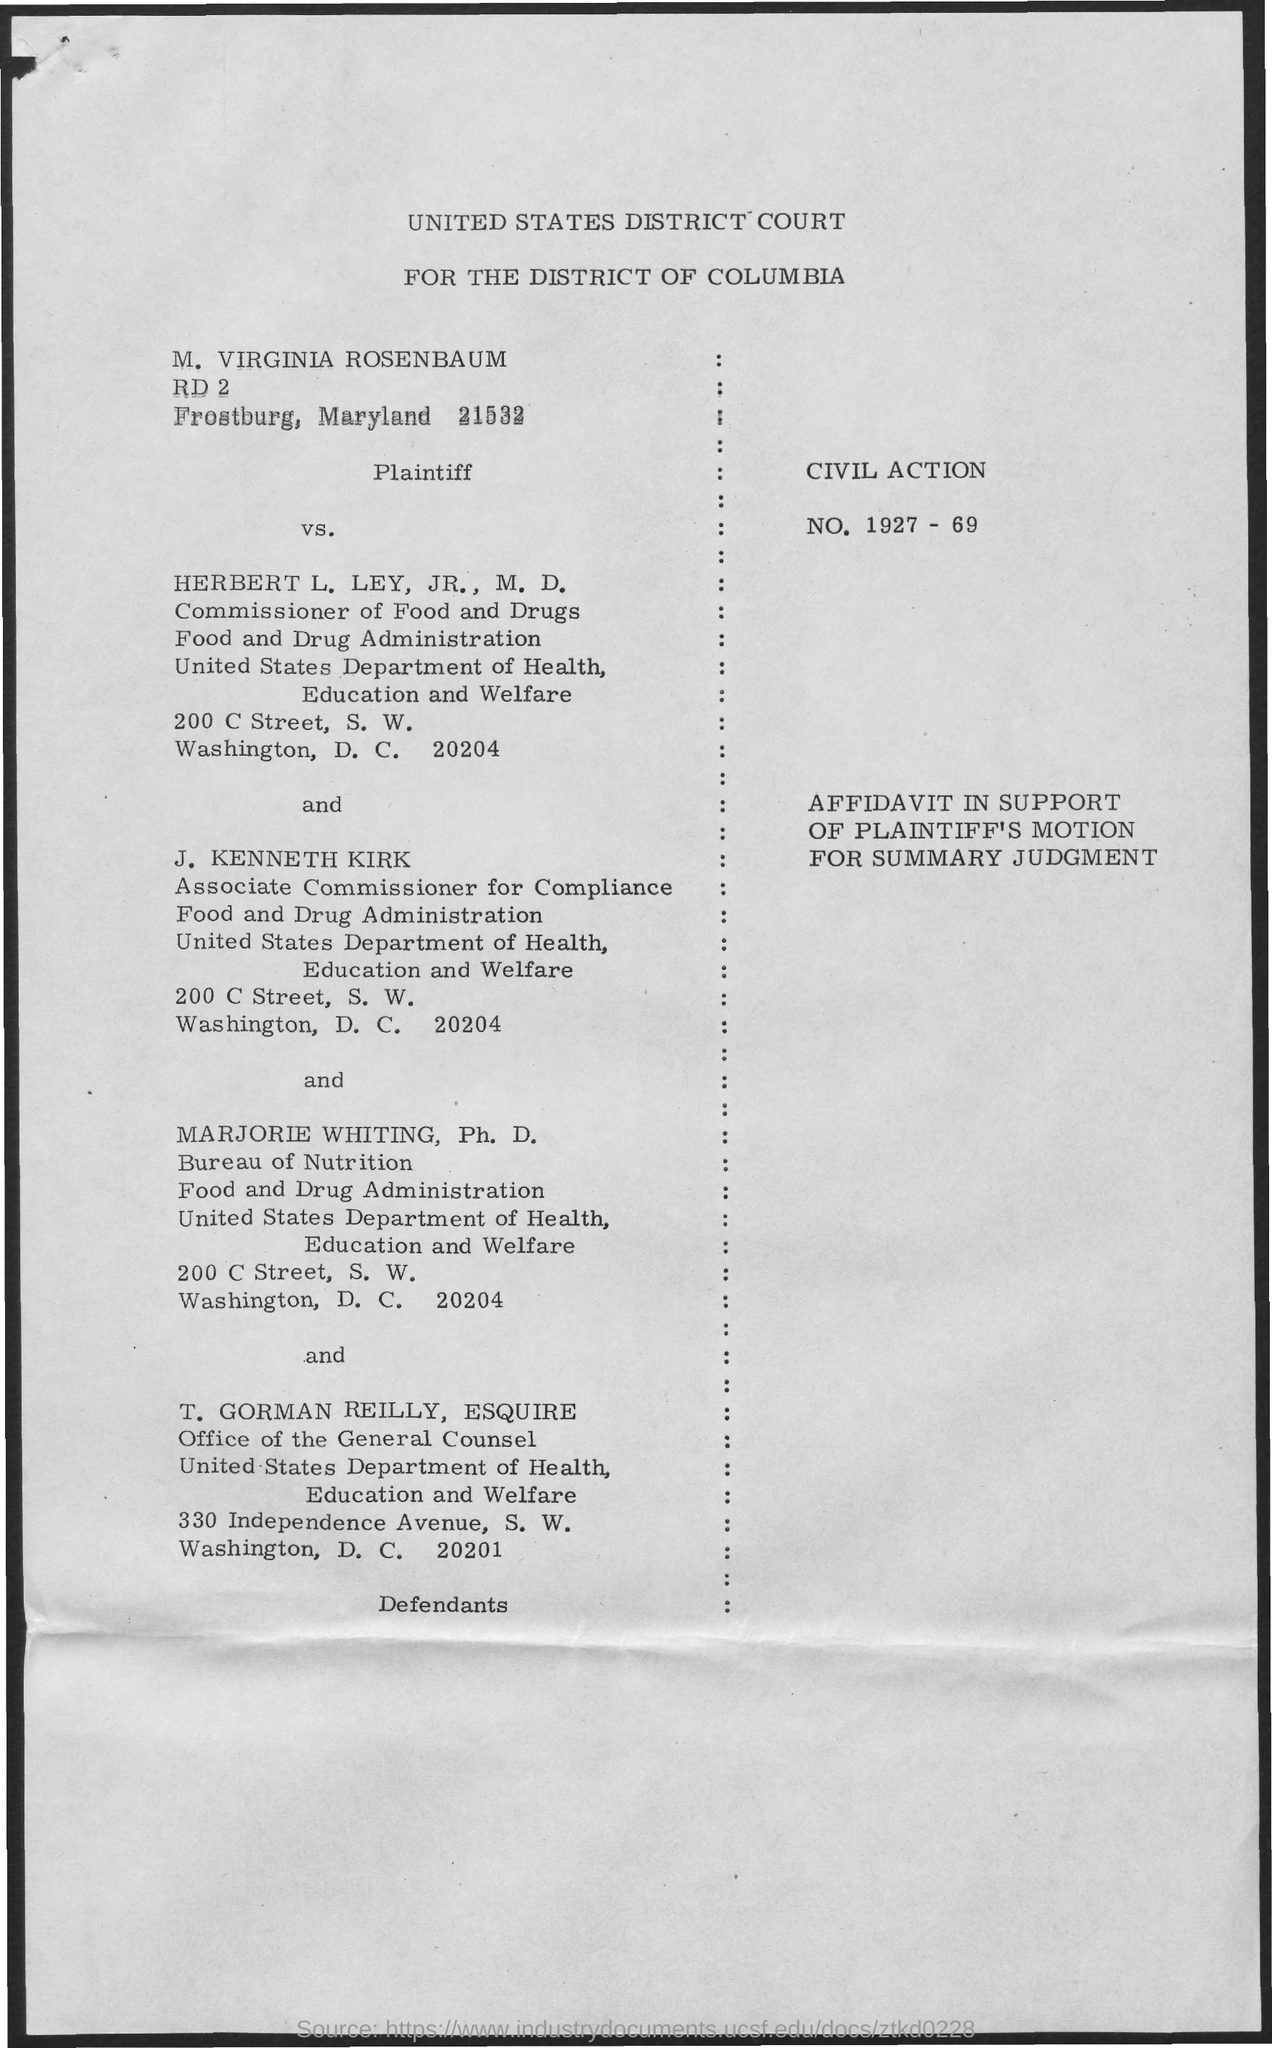Which court  is mentioned in the title?
Your answer should be very brief. UNITED STATES DISTRICT COURT FOR THE DISTRICT OF COLUMBIA. What is the Plaintiff?
Your answer should be compact. CIVIL ACTION. Who is HERBERT L. LEY, JR., M.D.?
Keep it short and to the point. Commissioner of Food and Drugs. Who is the Associate Commissioner for Compliance?
Keep it short and to the point. J. KENNETH KIRK. 